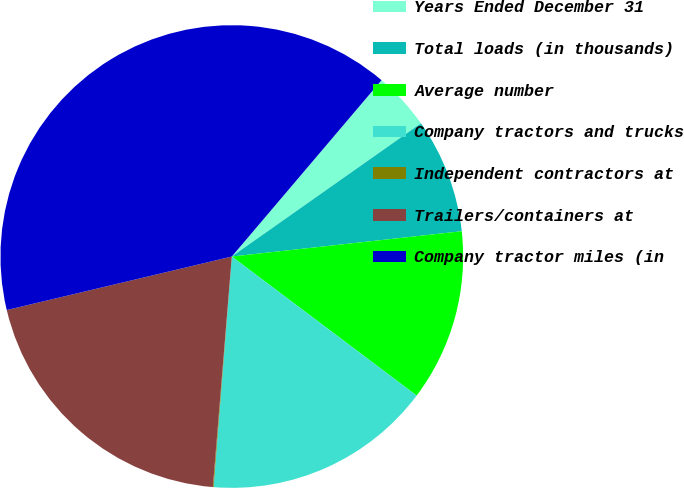<chart> <loc_0><loc_0><loc_500><loc_500><pie_chart><fcel>Years Ended December 31<fcel>Total loads (in thousands)<fcel>Average number<fcel>Company tractors and trucks<fcel>Independent contractors at<fcel>Trailers/containers at<fcel>Company tractor miles (in<nl><fcel>4.03%<fcel>8.02%<fcel>12.01%<fcel>15.99%<fcel>0.05%<fcel>19.98%<fcel>39.92%<nl></chart> 